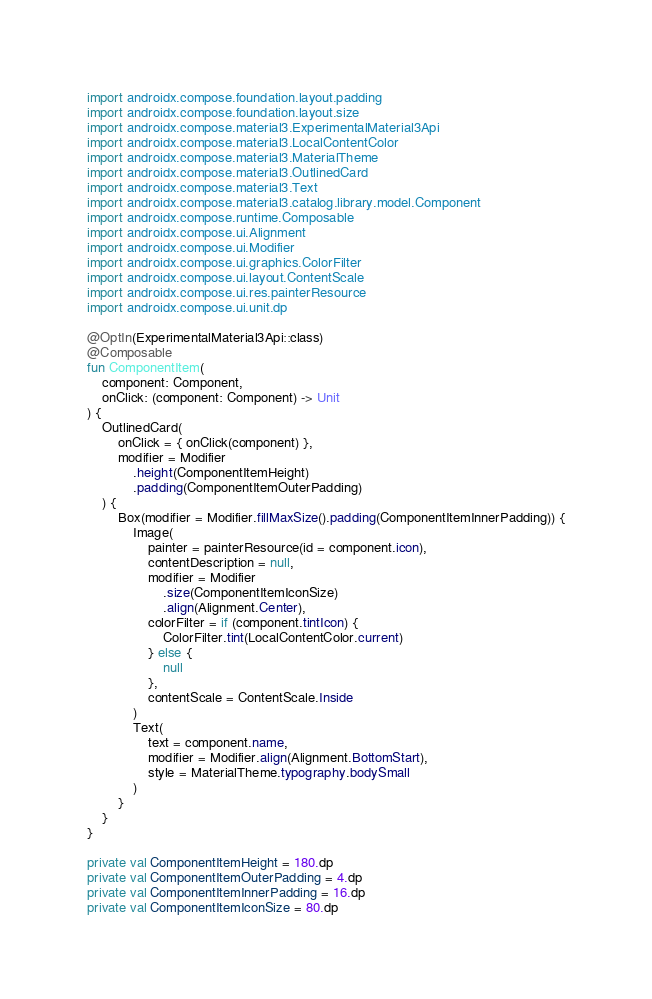<code> <loc_0><loc_0><loc_500><loc_500><_Kotlin_>import androidx.compose.foundation.layout.padding
import androidx.compose.foundation.layout.size
import androidx.compose.material3.ExperimentalMaterial3Api
import androidx.compose.material3.LocalContentColor
import androidx.compose.material3.MaterialTheme
import androidx.compose.material3.OutlinedCard
import androidx.compose.material3.Text
import androidx.compose.material3.catalog.library.model.Component
import androidx.compose.runtime.Composable
import androidx.compose.ui.Alignment
import androidx.compose.ui.Modifier
import androidx.compose.ui.graphics.ColorFilter
import androidx.compose.ui.layout.ContentScale
import androidx.compose.ui.res.painterResource
import androidx.compose.ui.unit.dp

@OptIn(ExperimentalMaterial3Api::class)
@Composable
fun ComponentItem(
    component: Component,
    onClick: (component: Component) -> Unit
) {
    OutlinedCard(
        onClick = { onClick(component) },
        modifier = Modifier
            .height(ComponentItemHeight)
            .padding(ComponentItemOuterPadding)
    ) {
        Box(modifier = Modifier.fillMaxSize().padding(ComponentItemInnerPadding)) {
            Image(
                painter = painterResource(id = component.icon),
                contentDescription = null,
                modifier = Modifier
                    .size(ComponentItemIconSize)
                    .align(Alignment.Center),
                colorFilter = if (component.tintIcon) {
                    ColorFilter.tint(LocalContentColor.current)
                } else {
                    null
                },
                contentScale = ContentScale.Inside
            )
            Text(
                text = component.name,
                modifier = Modifier.align(Alignment.BottomStart),
                style = MaterialTheme.typography.bodySmall
            )
        }
    }
}

private val ComponentItemHeight = 180.dp
private val ComponentItemOuterPadding = 4.dp
private val ComponentItemInnerPadding = 16.dp
private val ComponentItemIconSize = 80.dp
</code> 